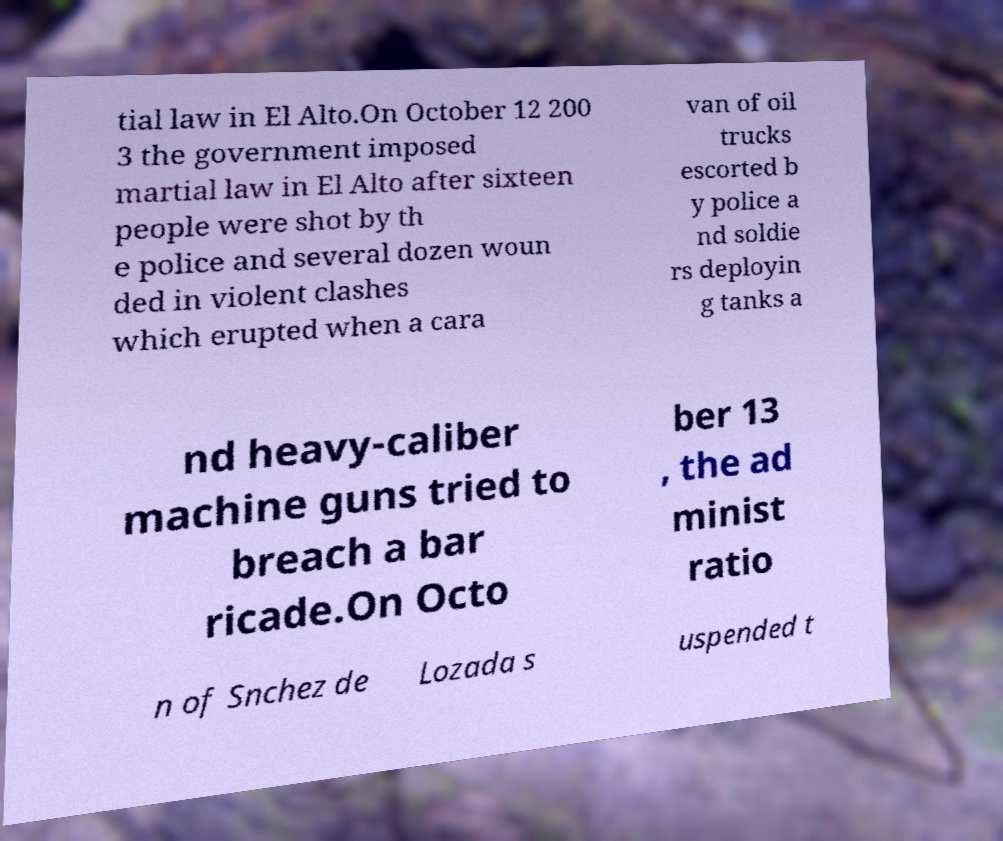Please identify and transcribe the text found in this image. tial law in El Alto.On October 12 200 3 the government imposed martial law in El Alto after sixteen people were shot by th e police and several dozen woun ded in violent clashes which erupted when a cara van of oil trucks escorted b y police a nd soldie rs deployin g tanks a nd heavy-caliber machine guns tried to breach a bar ricade.On Octo ber 13 , the ad minist ratio n of Snchez de Lozada s uspended t 